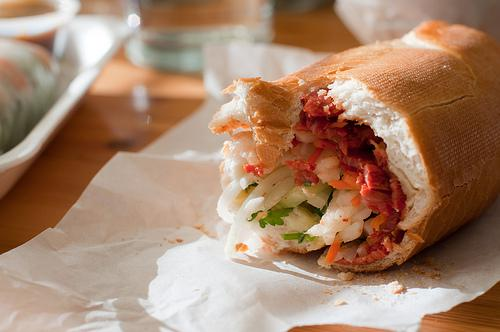Question: what food is there?
Choices:
A. Pizza.
B. Sandwich roll.
C. Pasta.
D. Sushi.
Answer with the letter. Answer: B Question: where is the sandwich?
Choices:
A. Table.
B. Counter.
C. Basket.
D. Bag.
Answer with the letter. Answer: A Question: what is in the sandwich?
Choices:
A. Ham.
B. Cheese.
C. Onions.
D. Tomatoes.
Answer with the letter. Answer: C 